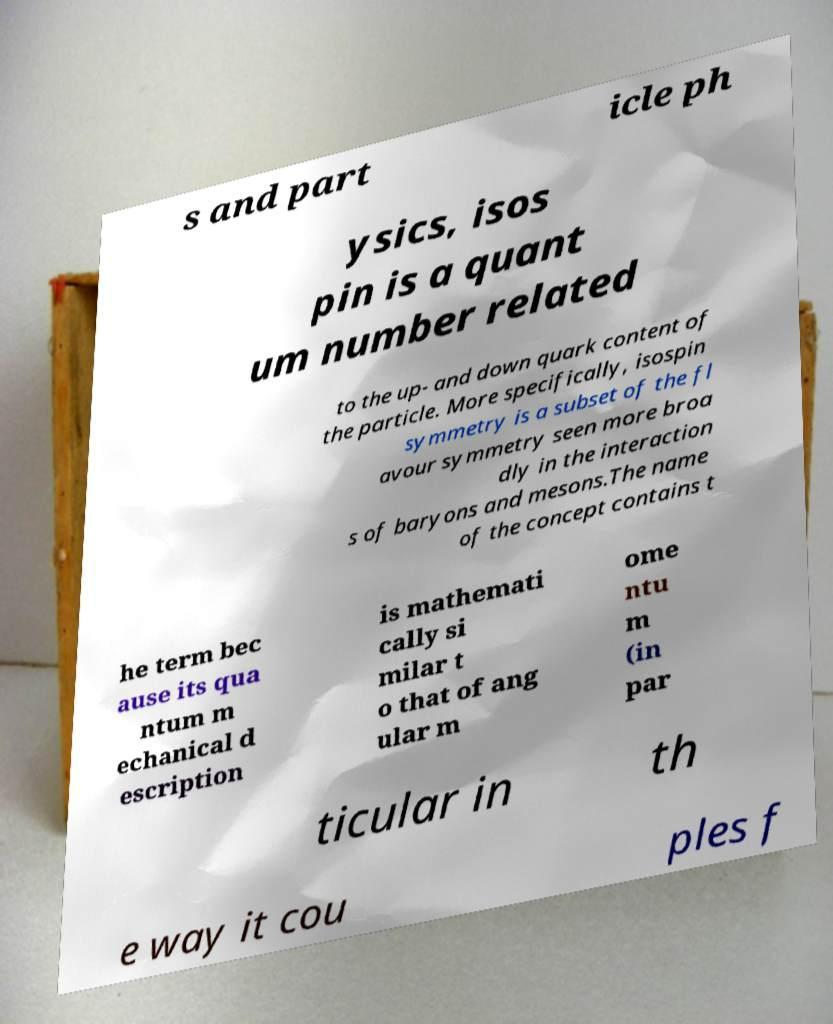Please identify and transcribe the text found in this image. s and part icle ph ysics, isos pin is a quant um number related to the up- and down quark content of the particle. More specifically, isospin symmetry is a subset of the fl avour symmetry seen more broa dly in the interaction s of baryons and mesons.The name of the concept contains t he term bec ause its qua ntum m echanical d escription is mathemati cally si milar t o that of ang ular m ome ntu m (in par ticular in th e way it cou ples f 